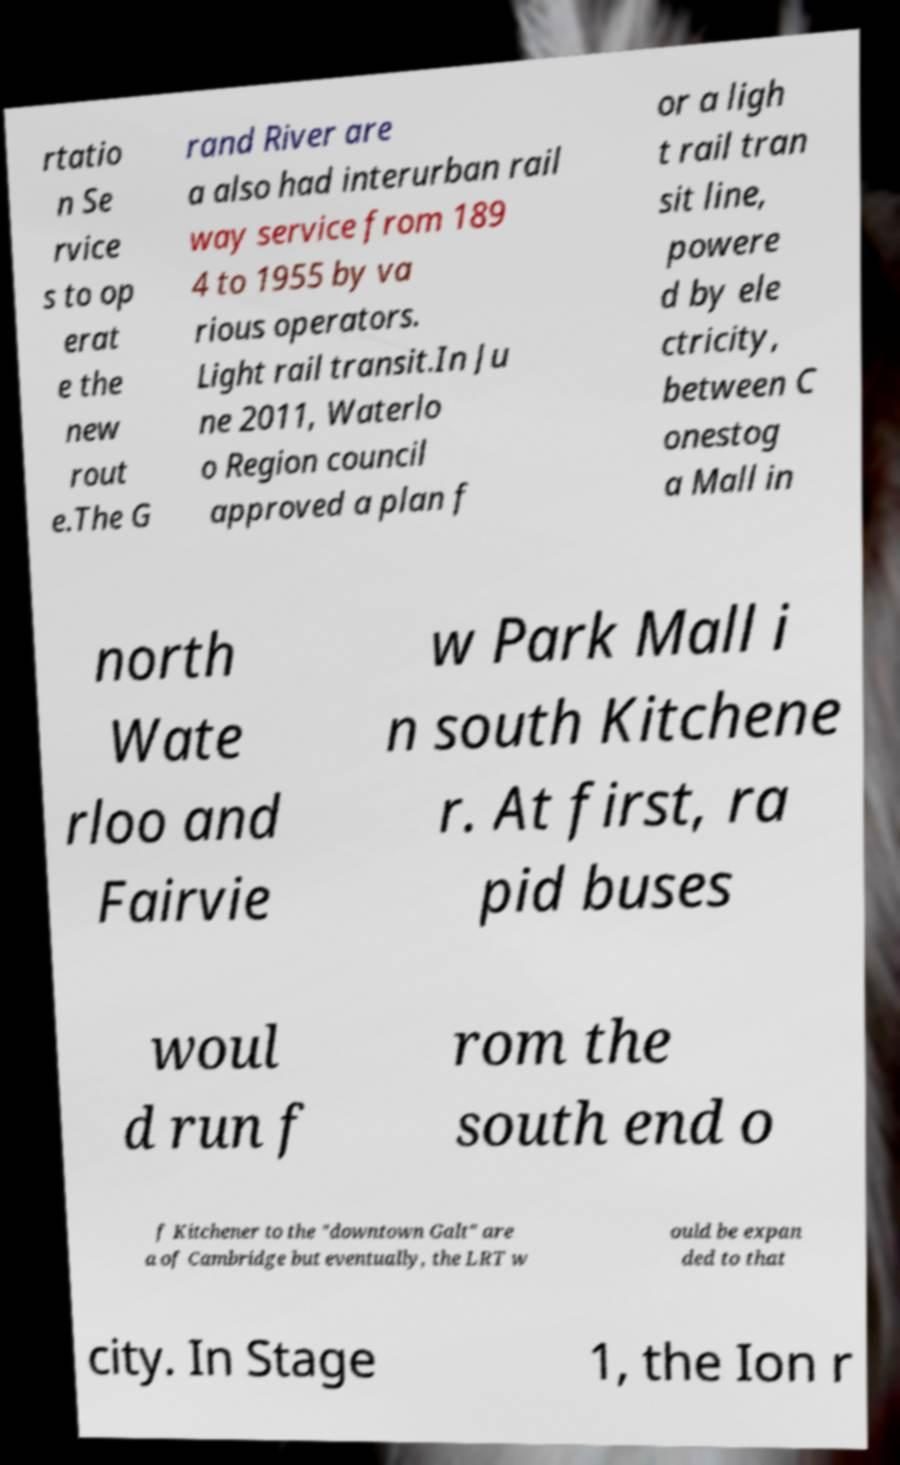I need the written content from this picture converted into text. Can you do that? rtatio n Se rvice s to op erat e the new rout e.The G rand River are a also had interurban rail way service from 189 4 to 1955 by va rious operators. Light rail transit.In Ju ne 2011, Waterlo o Region council approved a plan f or a ligh t rail tran sit line, powere d by ele ctricity, between C onestog a Mall in north Wate rloo and Fairvie w Park Mall i n south Kitchene r. At first, ra pid buses woul d run f rom the south end o f Kitchener to the "downtown Galt" are a of Cambridge but eventually, the LRT w ould be expan ded to that city. In Stage 1, the Ion r 